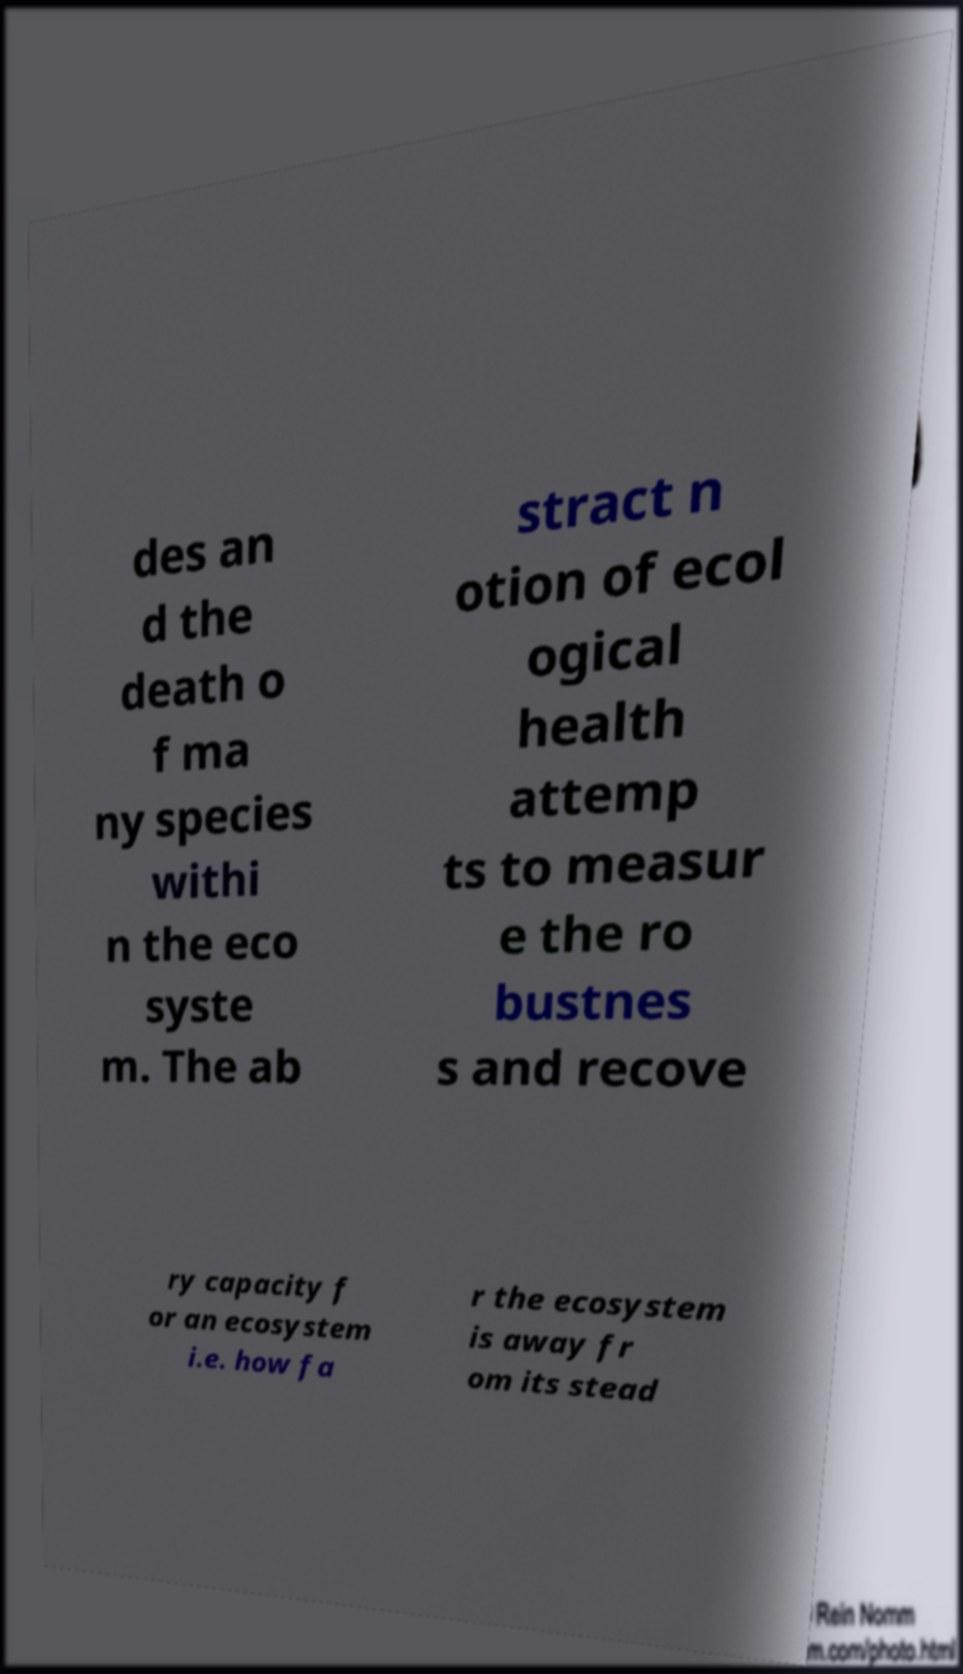What messages or text are displayed in this image? I need them in a readable, typed format. des an d the death o f ma ny species withi n the eco syste m. The ab stract n otion of ecol ogical health attemp ts to measur e the ro bustnes s and recove ry capacity f or an ecosystem i.e. how fa r the ecosystem is away fr om its stead 